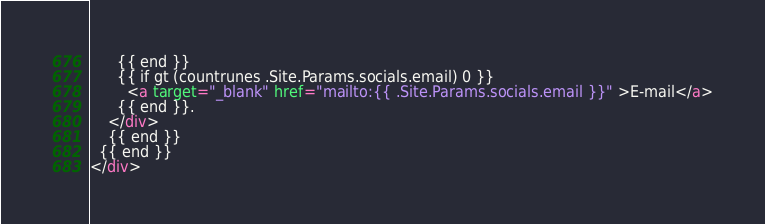<code> <loc_0><loc_0><loc_500><loc_500><_HTML_>      {{ end }}
      {{ if gt (countrunes .Site.Params.socials.email) 0 }}
        <a target="_blank" href="mailto:{{ .Site.Params.socials.email }}" >E-mail</a>
      {{ end }}.
    </div>
    {{ end }}
  {{ end }}
</div>
</code> 